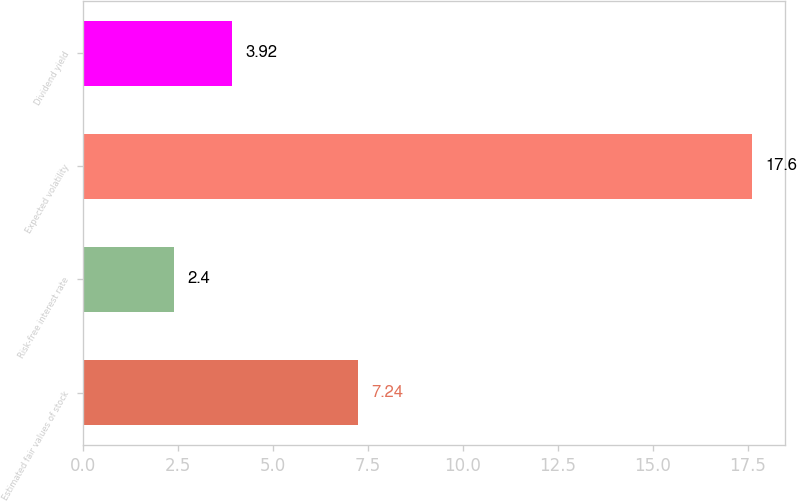Convert chart. <chart><loc_0><loc_0><loc_500><loc_500><bar_chart><fcel>Estimated fair values of stock<fcel>Risk-free interest rate<fcel>Expected volatility<fcel>Dividend yield<nl><fcel>7.24<fcel>2.4<fcel>17.6<fcel>3.92<nl></chart> 